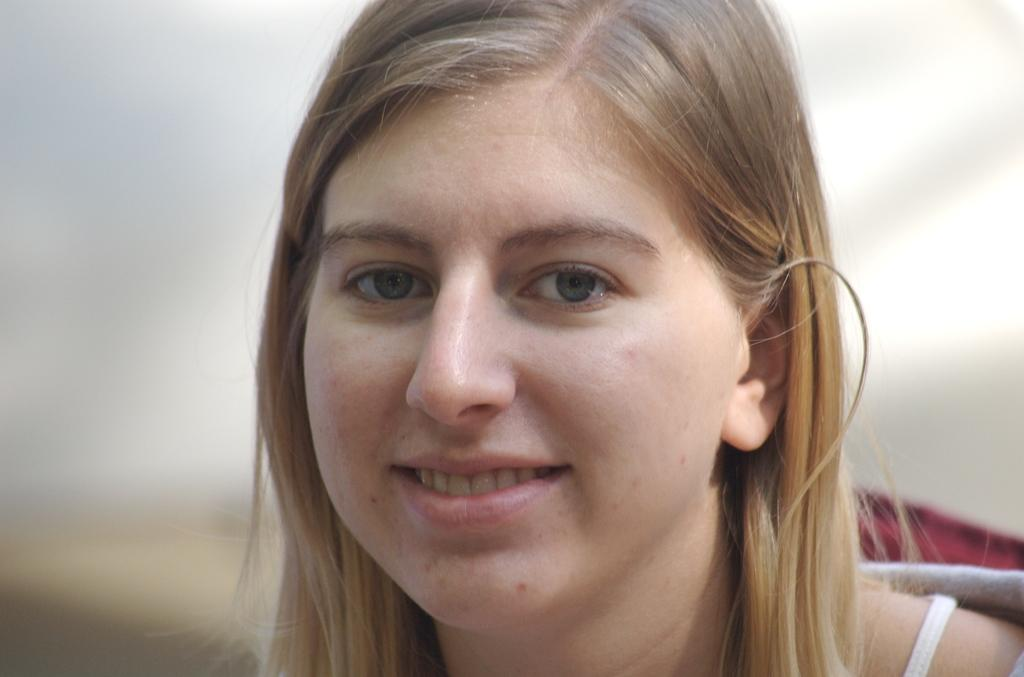Who is present in the image? There is a lady in the image. What is the lady doing in the image? The lady is smiling in the image. What is the lady wearing in the image? The lady is wearing a dress in the image. What type of sweater is the lady wearing in the image? The lady is not wearing a sweater in the image; she is wearing a dress. How many wheels can be seen on the lady in the image? There are no wheels present on the lady in the image. 